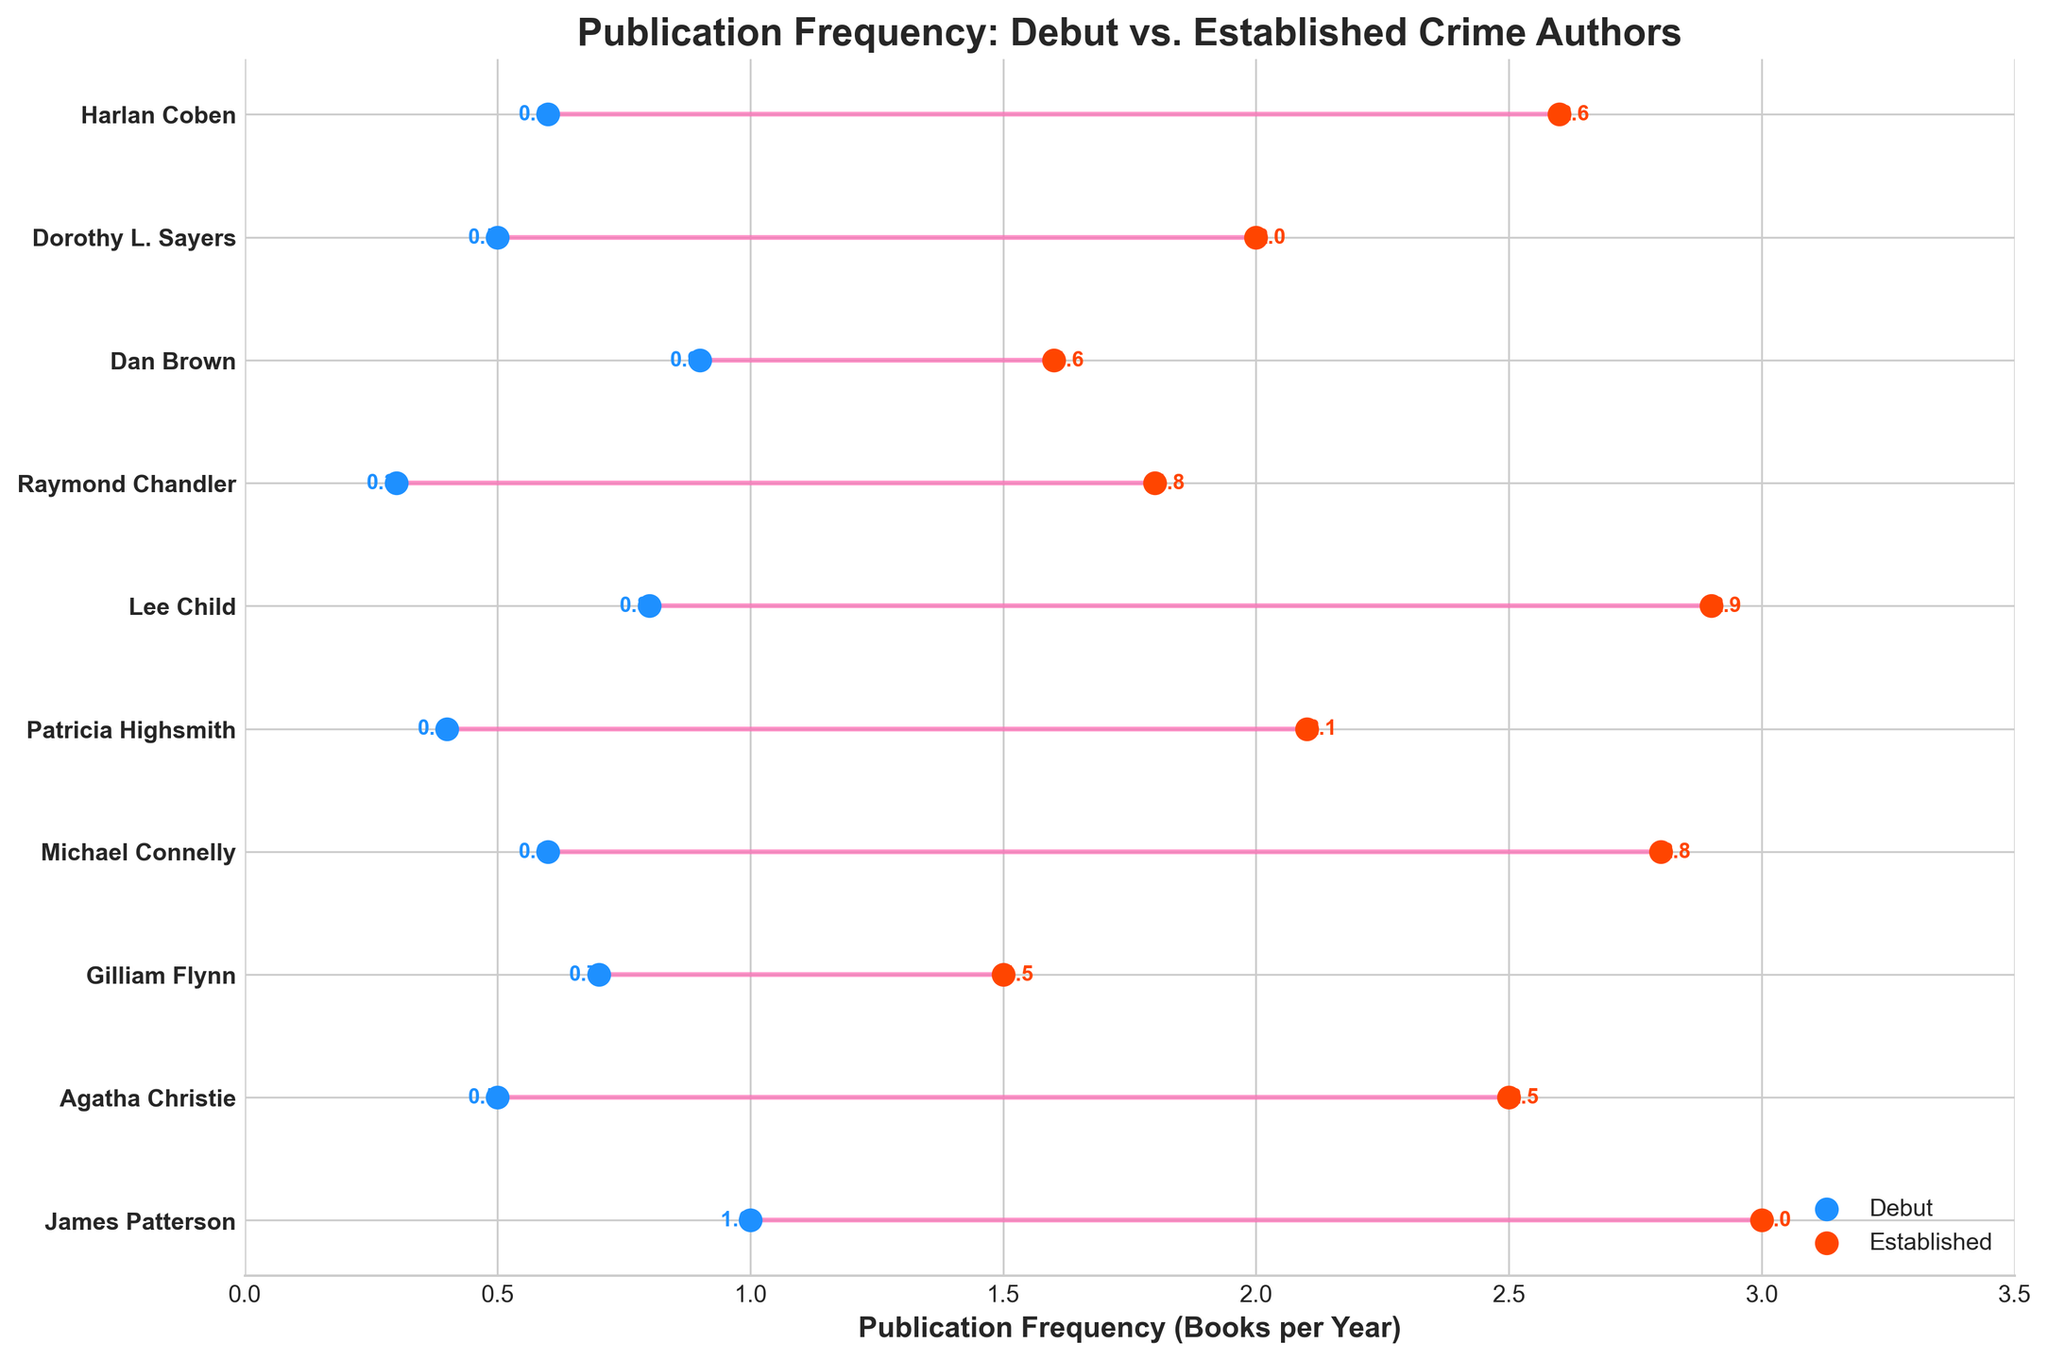What is the title of the figure? The title is found at the top of the figure. It reads, "Publication Frequency: Debut vs. Established Crime Authors".
Answer: Publication Frequency: Debut vs. Established Crime Authors How are the debut and established publication frequencies visually differentiated? Debut publication frequencies are represented by blue dots, while established publication frequencies are represented by red dots. The connecting lines between them are pink.
Answer: Blue dots for debut, red dots for established, pink connecting lines Which author has the highest publication frequency as an established author according to the figure? To find the highest publication frequency among established authors, look for the red dot plotted at the highest value along the x-axis. According to the plot, James Patterson has the highest established publication frequency at 3 books per year.
Answer: James Patterson What are the publication frequencies for Michael Connelly as a debut and established author, and what is the difference? Michael Connelly's debut frequency is 0.6, and his established frequency is 2.8. The difference is calculated as 2.8 - 0.6 = 2.2.
Answer: Debut: 0.6, Established: 2.8, Difference: 2.2 Which author shows the greatest increase in publication frequency from debut to established? To determine the greatest increase, compare the differences for each author. For James Patterson, it's an increase of 2 (3 - 1), for Agatha Christie, it's an increase of 2 (2.5 - 0.5), etc. James Patterson and Lee Child both have an increase of 2.2 (Lee Child: 2.9 - 0.8). Between them, Lee Child shows the greatest increase.
Answer: Lee Child What is the average publication frequency for established authors? Sum the frequencies for all established authors and divide by the number of authors. (3 + 2.5 + 1.5 + 2.8 + 2.1 + 2.9 + 1.8 + 1.6 + 2.0 + 2.6) / 10 = 22.8 / 10 = 2.28.
Answer: 2.28 Are there any authors whose established publication frequency is less than double their debut frequency? Compare each author's established figure with twice their debut; for example, twice 1 (James Patterson's debut) is 2. No authors meet this condition; all established frequencies are more than double their debut.
Answer: No Which two authors have the same debut publication frequency? Scan the blue dots on the left for repeating values. Dorothy L. Sayers and Agatha Christie both debut at 0.5.
Answer: Dorothy L. Sayers and Agatha Christie Do the established publication frequencies generally follow the same order as the debut frequencies? Compare the order of authors in terms of debut frequencies and established frequencies. While there are changes (e.g., Lee Child's established is higher), generally, authors with high debut rates tend to have high established rates too.
Answer: Generally yes What is the range of publication frequencies among established authors? To find the range, subtract the minimum established frequency from the maximum. The max is 3 (James Patterson), and the min is 1.5 (Gillian Flynn). The range is 3 - 1.5 = 1.5.
Answer: 1.5 